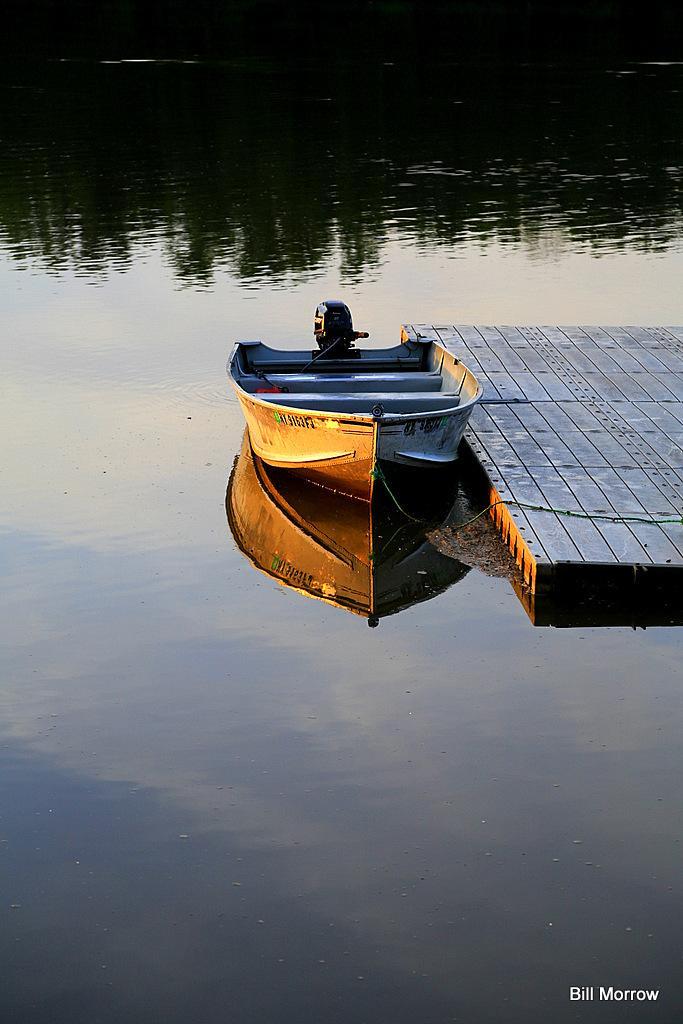In one or two sentences, can you explain what this image depicts? In this picture we can see a boat here, behind it there is a raft, at the bottom there is water, we can see some text here. 